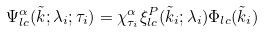Convert formula to latex. <formula><loc_0><loc_0><loc_500><loc_500>\Psi _ { l c } ^ { \alpha } ( \tilde { k } ; \lambda _ { i } ; \tau _ { i } ) = \chi _ { \tau _ { i } } ^ { \alpha } \xi _ { l c } ^ { P } ( \tilde { k } _ { i } ; \lambda _ { i } ) \Phi _ { l c } ( \tilde { k } _ { i } )</formula> 